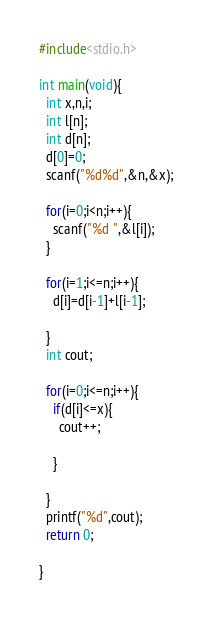Convert code to text. <code><loc_0><loc_0><loc_500><loc_500><_C_>#include<stdio.h>

int main(void){
  int x,n,i;
  int l[n];
  int d[n];
  d[0]=0;
  scanf("%d%d",&n,&x);
  
  for(i=0;i<n;i++){
    scanf("%d ",&l[i]);
  }
  
  for(i=1;i<=n;i++){
    d[i]=d[i-1]+l[i-1];
  
  }
  int cout;
  
  for(i=0;i<=n;i++){
    if(d[i]<=x){
      cout++;
    
    }
  
  }
  printf("%d",cout);
  return 0;

}</code> 